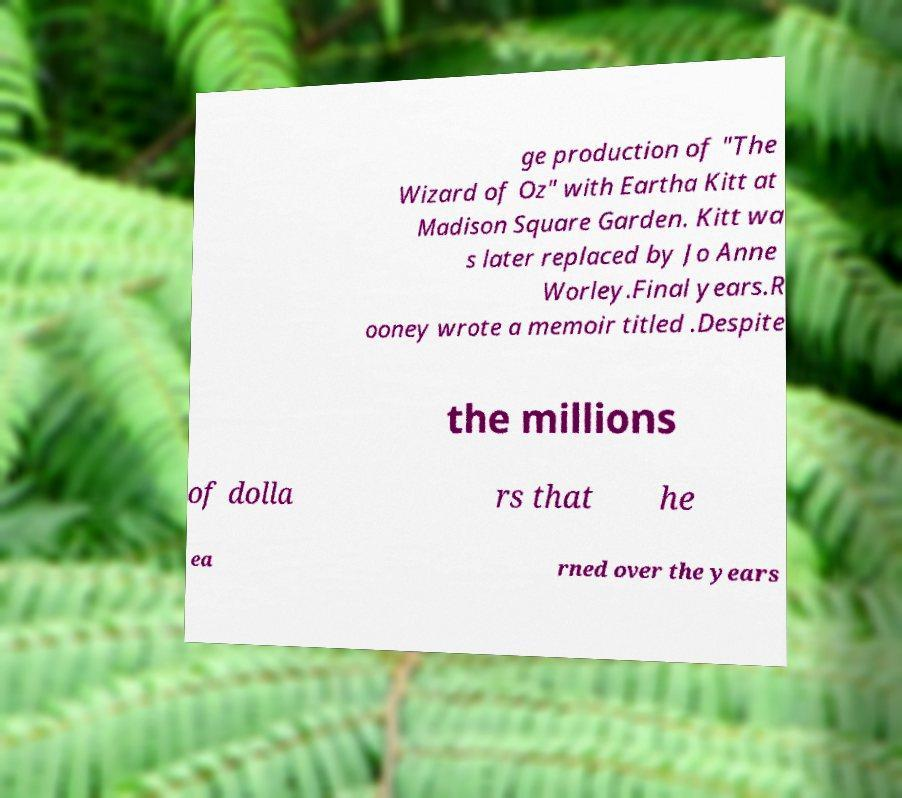Could you extract and type out the text from this image? ge production of "The Wizard of Oz" with Eartha Kitt at Madison Square Garden. Kitt wa s later replaced by Jo Anne Worley.Final years.R ooney wrote a memoir titled .Despite the millions of dolla rs that he ea rned over the years 